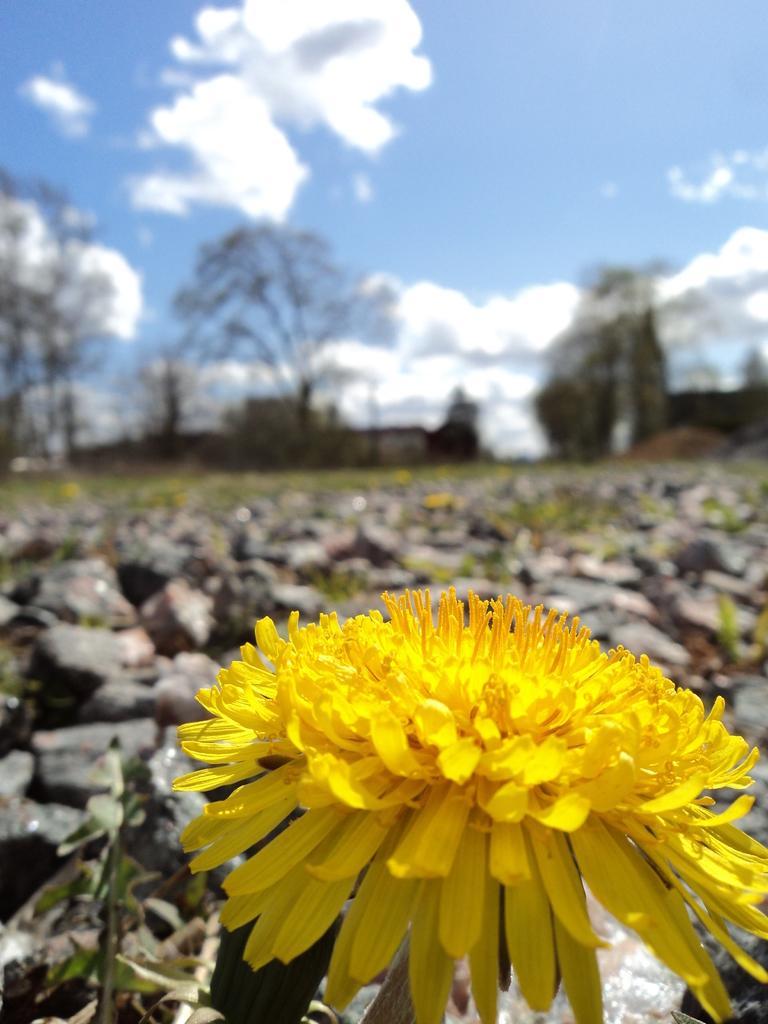How would you summarize this image in a sentence or two? This image is taken outdoors. At the top of the image there is the sky with clouds. In the background there are a few trees. At the bottom of the image there is a flower which is yellow in color. In the middle of the image there are many plants with green leaves. 